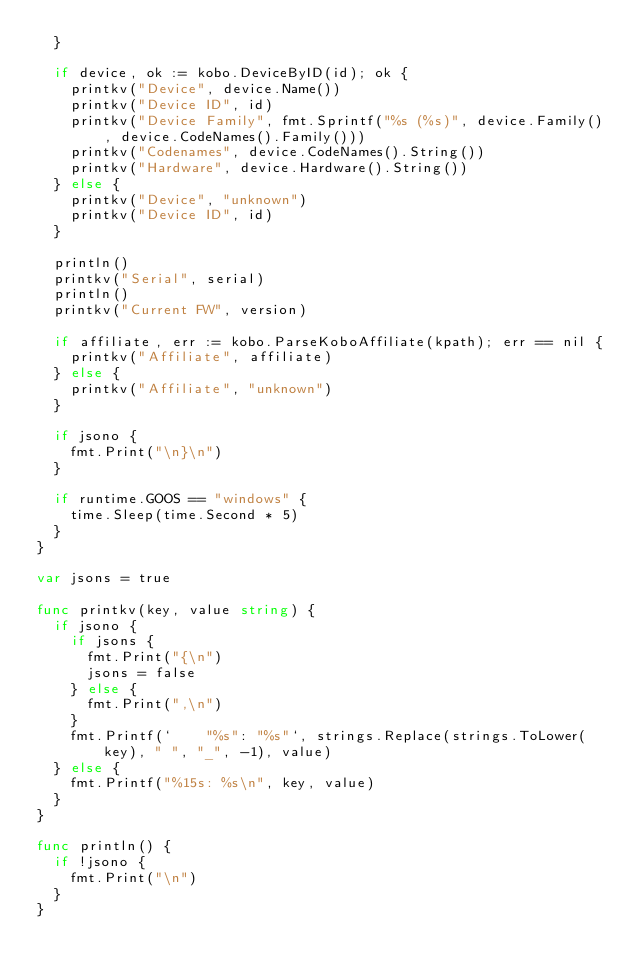Convert code to text. <code><loc_0><loc_0><loc_500><loc_500><_Go_>	}

	if device, ok := kobo.DeviceByID(id); ok {
		printkv("Device", device.Name())
		printkv("Device ID", id)
		printkv("Device Family", fmt.Sprintf("%s (%s)", device.Family(), device.CodeNames().Family()))
		printkv("Codenames", device.CodeNames().String())
		printkv("Hardware", device.Hardware().String())
	} else {
		printkv("Device", "unknown")
		printkv("Device ID", id)
	}

	println()
	printkv("Serial", serial)
	println()
	printkv("Current FW", version)

	if affiliate, err := kobo.ParseKoboAffiliate(kpath); err == nil {
		printkv("Affiliate", affiliate)
	} else {
		printkv("Affiliate", "unknown")
	}

	if jsono {
		fmt.Print("\n}\n")
	}

	if runtime.GOOS == "windows" {
		time.Sleep(time.Second * 5)
	}
}

var jsons = true

func printkv(key, value string) {
	if jsono {
		if jsons {
			fmt.Print("{\n")
			jsons = false
		} else {
			fmt.Print(",\n")
		}
		fmt.Printf(`    "%s": "%s"`, strings.Replace(strings.ToLower(key), " ", "_", -1), value)
	} else {
		fmt.Printf("%15s: %s\n", key, value)
	}
}

func println() {
	if !jsono {
		fmt.Print("\n")
	}
}
</code> 